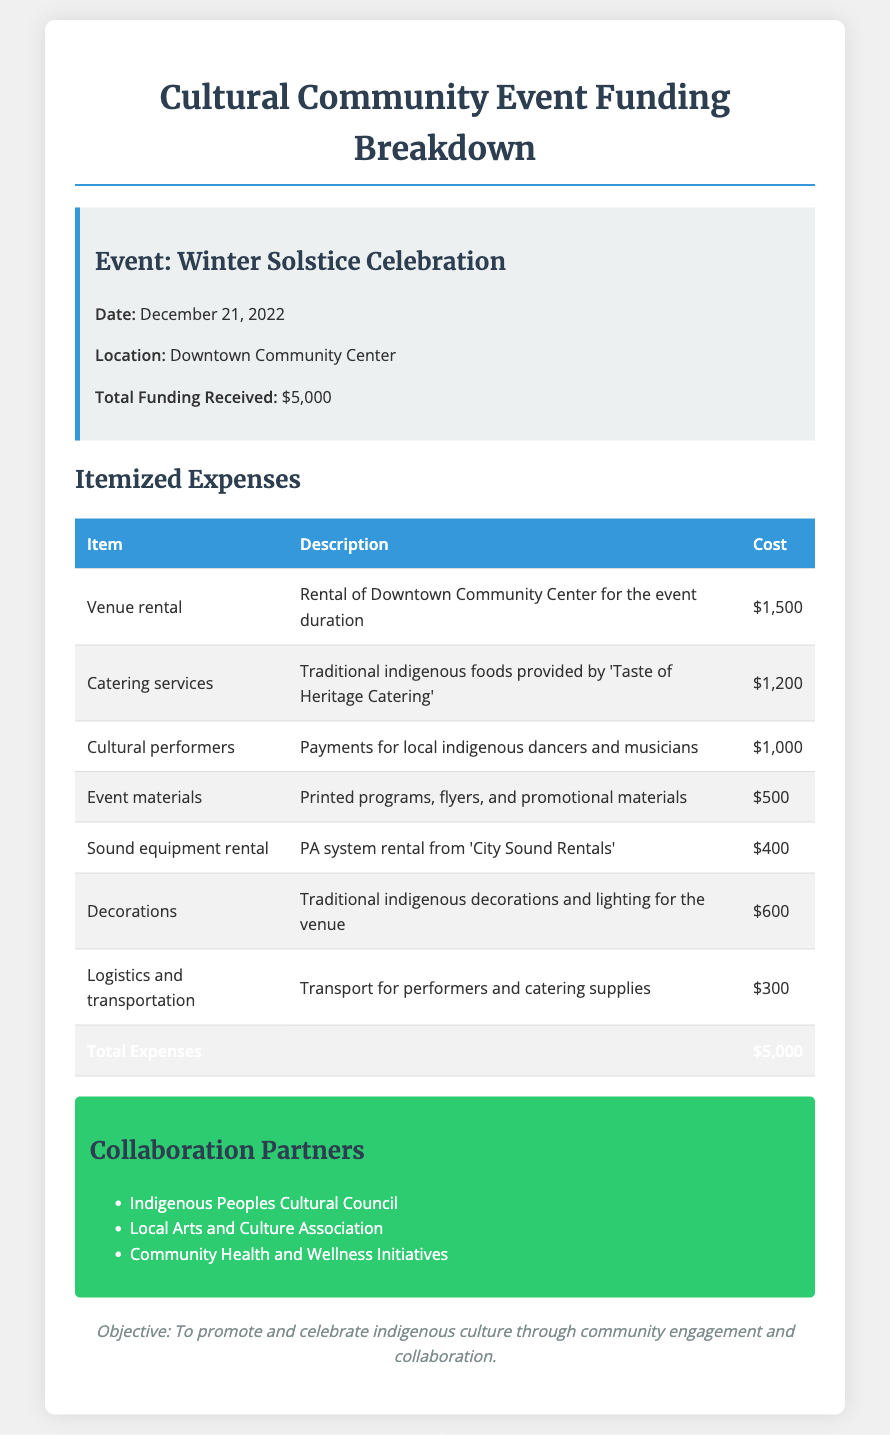What is the event date? The event date is specified in the document under the event details section.
Answer: December 21, 2022 What is the total funding received? The total funding received can be found in the event details section.
Answer: $5,000 How much was spent on cultural performers? The amount spent on cultural performers is listed in the itemized expenses table.
Answer: $1,000 What is the venue for the event? The venue is mentioned in the event details section.
Answer: Downtown Community Center Who provided the catering services? The catering service provider is identified in the itemized expenses.
Answer: Taste of Heritage Catering What is the objective of the event? The objective is stated at the end of the document.
Answer: To promote and celebrate indigenous culture through community engagement and collaboration How much was allocated for decorations? The cost allocation for decorations is available in the itemized expenses.
Answer: $600 List one collaboration partner. Collaboration partners are mentioned in a specific section of the document.
Answer: Indigenous Peoples Cultural Council What was the total expense amount? The total expense amount is presented in the itemized expenses table.
Answer: $5,000 